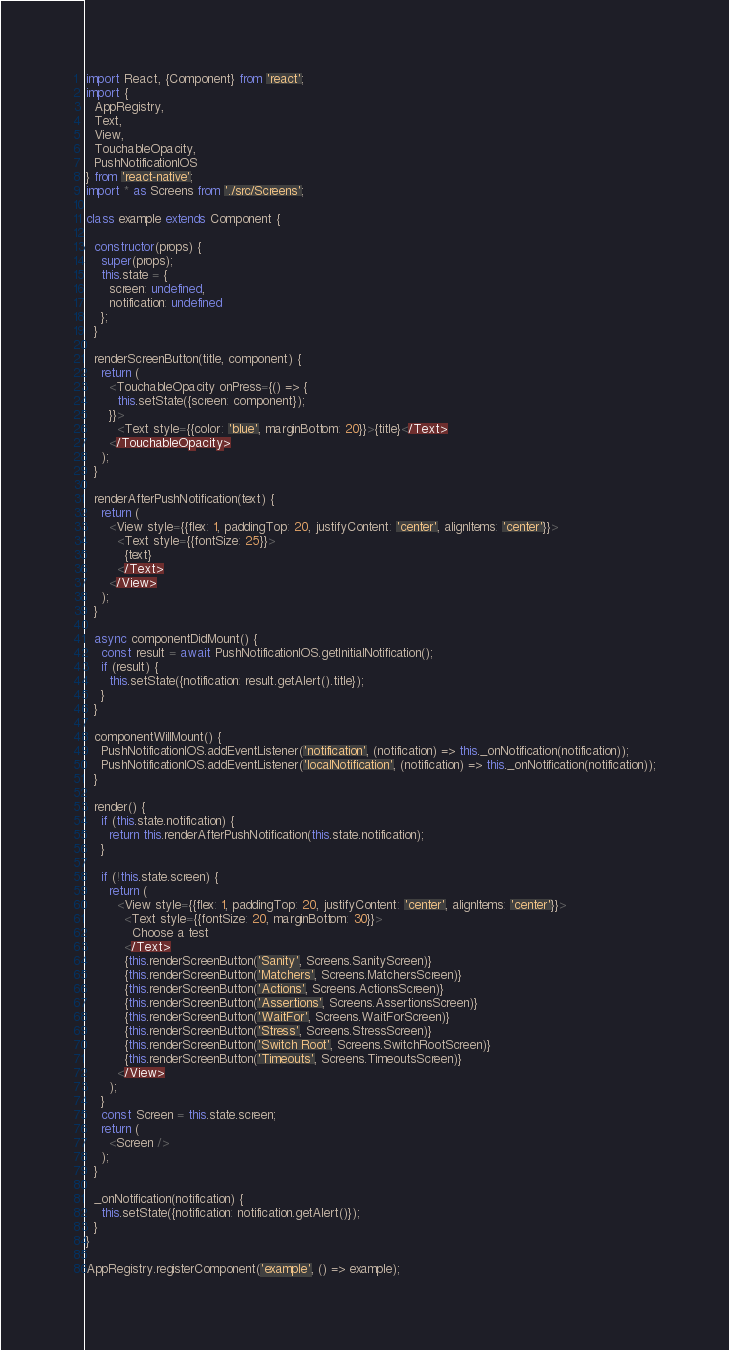Convert code to text. <code><loc_0><loc_0><loc_500><loc_500><_JavaScript_>import React, {Component} from 'react';
import {
  AppRegistry,
  Text,
  View,
  TouchableOpacity,
  PushNotificationIOS
} from 'react-native';
import * as Screens from './src/Screens';

class example extends Component {

  constructor(props) {
    super(props);
    this.state = {
      screen: undefined,
      notification: undefined
    };
  }

  renderScreenButton(title, component) {
    return (
      <TouchableOpacity onPress={() => {
        this.setState({screen: component});
      }}>
        <Text style={{color: 'blue', marginBottom: 20}}>{title}</Text>
      </TouchableOpacity>
    );
  }

  renderAfterPushNotification(text) {
    return (
      <View style={{flex: 1, paddingTop: 20, justifyContent: 'center', alignItems: 'center'}}>
        <Text style={{fontSize: 25}}>
          {text}
        </Text>
      </View>
    );
  }

  async componentDidMount() {
    const result = await PushNotificationIOS.getInitialNotification();
    if (result) {
      this.setState({notification: result.getAlert().title});
    }
  }

  componentWillMount() {
    PushNotificationIOS.addEventListener('notification', (notification) => this._onNotification(notification));
    PushNotificationIOS.addEventListener('localNotification', (notification) => this._onNotification(notification));
  }

  render() {
    if (this.state.notification) {
      return this.renderAfterPushNotification(this.state.notification);
    }

    if (!this.state.screen) {
      return (
        <View style={{flex: 1, paddingTop: 20, justifyContent: 'center', alignItems: 'center'}}>
          <Text style={{fontSize: 20, marginBottom: 30}}>
            Choose a test
          </Text>
          {this.renderScreenButton('Sanity', Screens.SanityScreen)}
          {this.renderScreenButton('Matchers', Screens.MatchersScreen)}
          {this.renderScreenButton('Actions', Screens.ActionsScreen)}
          {this.renderScreenButton('Assertions', Screens.AssertionsScreen)}
          {this.renderScreenButton('WaitFor', Screens.WaitForScreen)}
          {this.renderScreenButton('Stress', Screens.StressScreen)}
          {this.renderScreenButton('Switch Root', Screens.SwitchRootScreen)}
          {this.renderScreenButton('Timeouts', Screens.TimeoutsScreen)}
        </View>
      );
    }
    const Screen = this.state.screen;
    return (
      <Screen />
    );
  }

  _onNotification(notification) {
    this.setState({notification: notification.getAlert()});
  }
}

AppRegistry.registerComponent('example', () => example);
</code> 